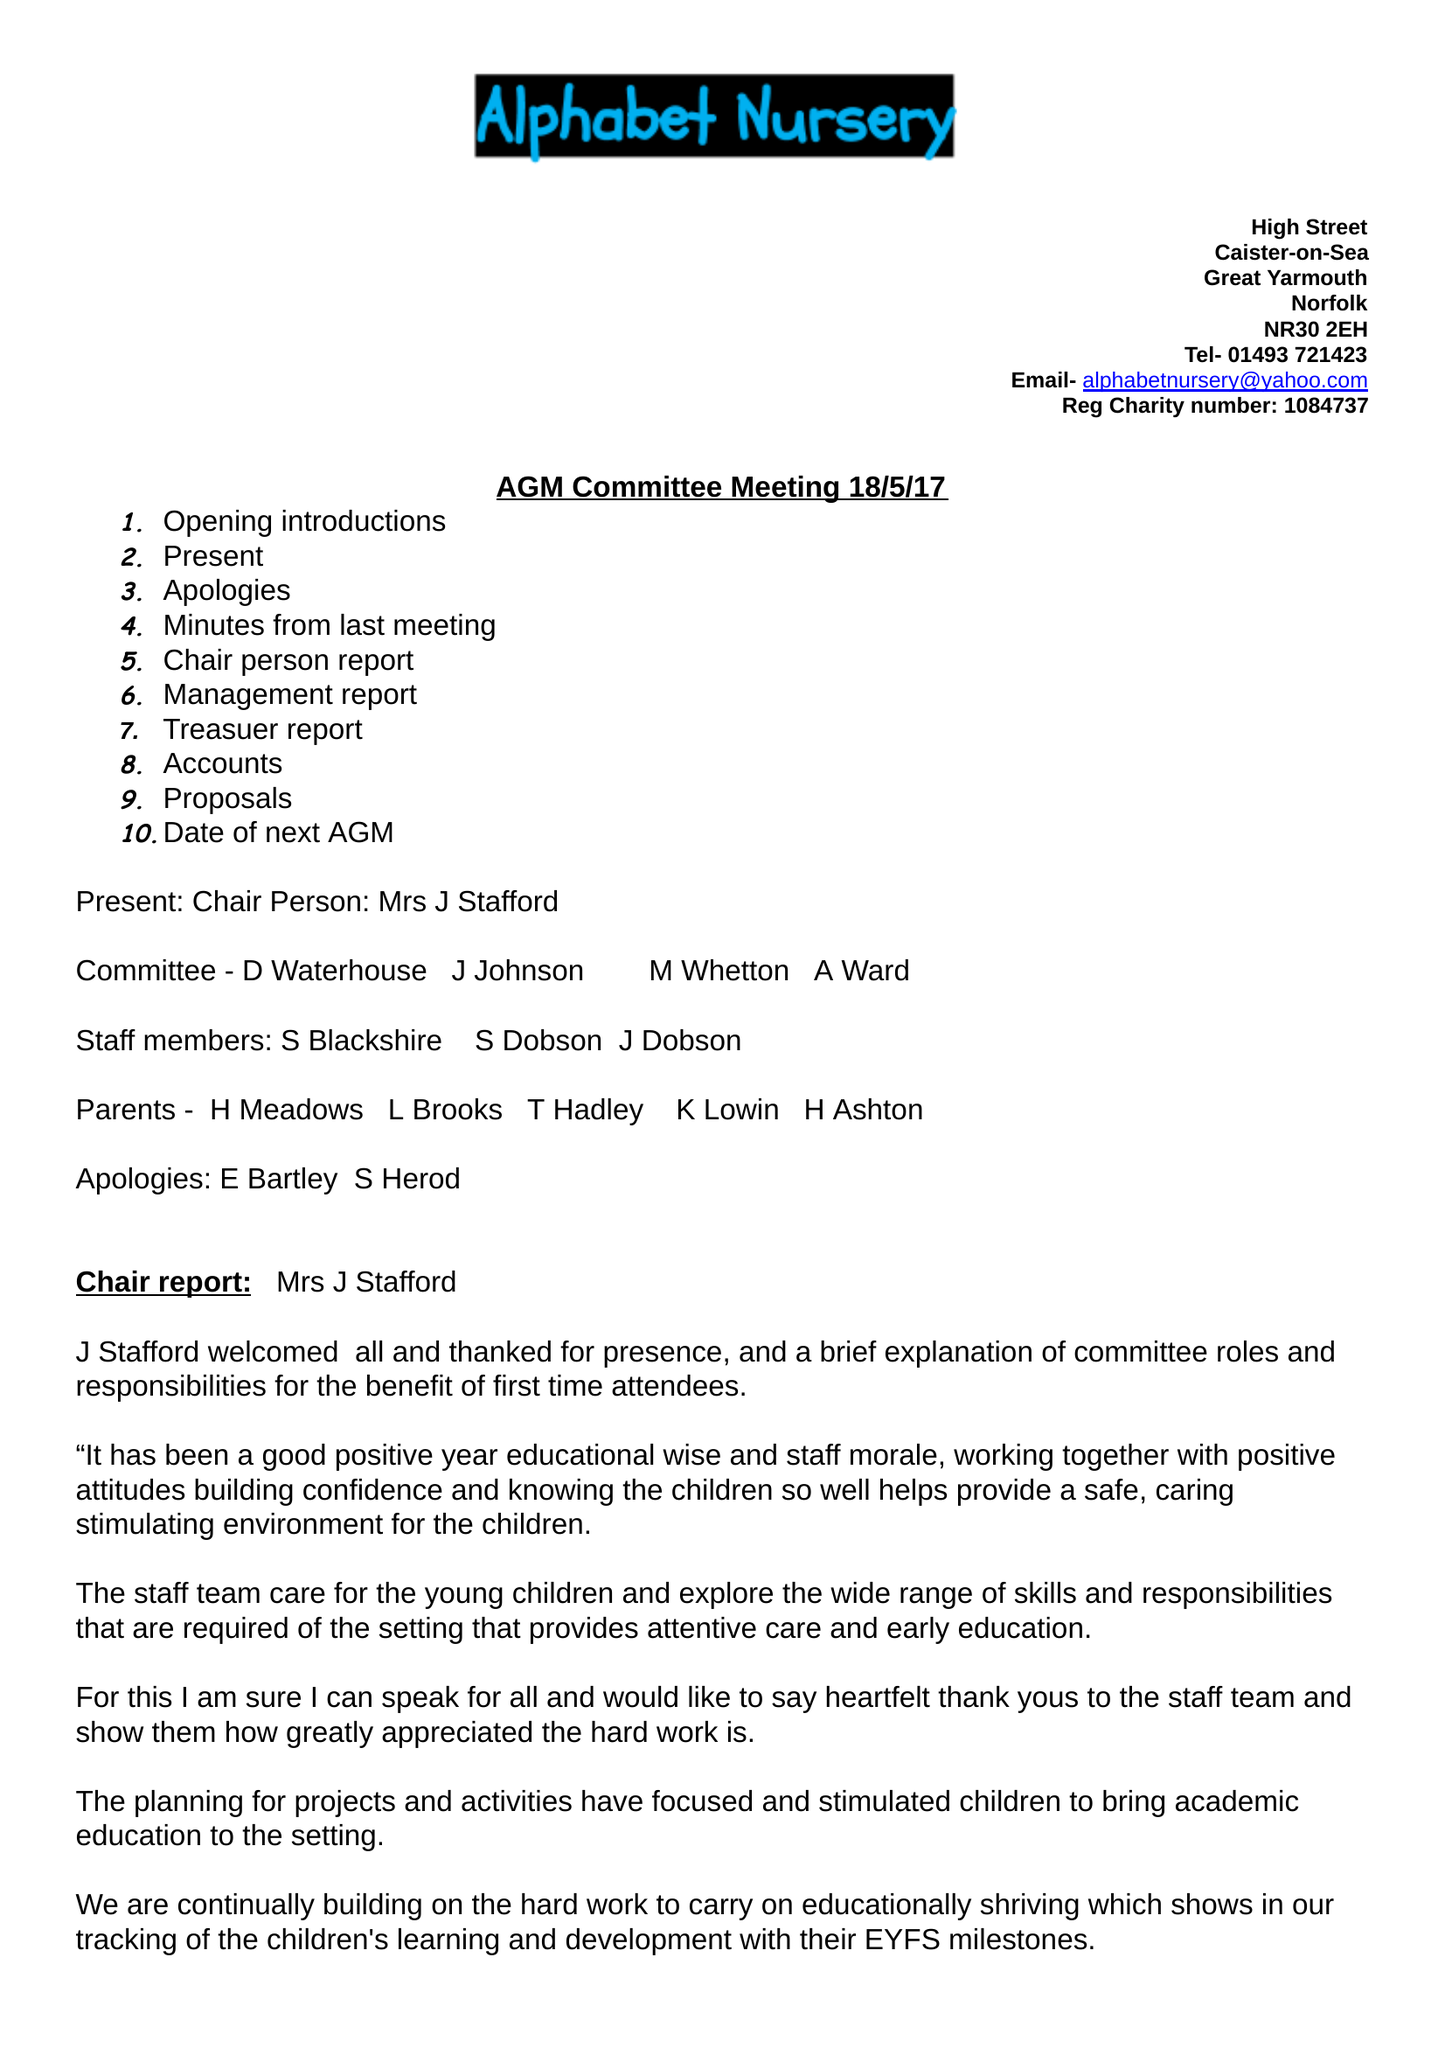What is the value for the income_annually_in_british_pounds?
Answer the question using a single word or phrase. 36550.00 